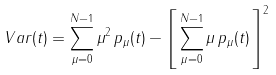<formula> <loc_0><loc_0><loc_500><loc_500>V a r ( t ) = \sum _ { \mu = 0 } ^ { N - 1 } \mu ^ { 2 } \, p _ { \mu } ( t ) - \left [ \, \sum _ { \mu = 0 } ^ { N - 1 } \mu \, p _ { \mu } ( t ) \, \right ] ^ { 2 }</formula> 